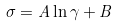<formula> <loc_0><loc_0><loc_500><loc_500>\sigma = A \ln \gamma + B</formula> 